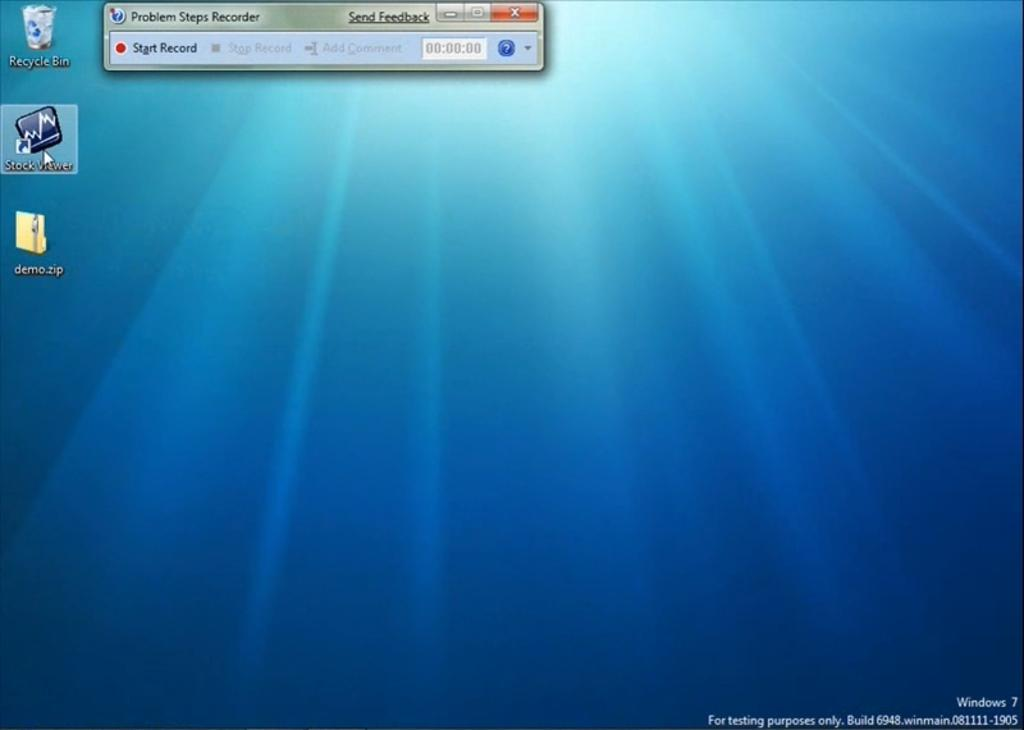<image>
Offer a succinct explanation of the picture presented. A windows 7 screen with a recycle bin icon on it. 